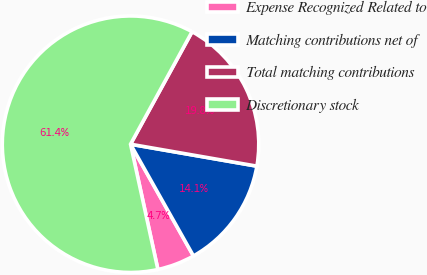Convert chart to OTSL. <chart><loc_0><loc_0><loc_500><loc_500><pie_chart><fcel>Expense Recognized Related to<fcel>Matching contributions net of<fcel>Total matching contributions<fcel>Discretionary stock<nl><fcel>4.74%<fcel>14.1%<fcel>19.77%<fcel>61.39%<nl></chart> 